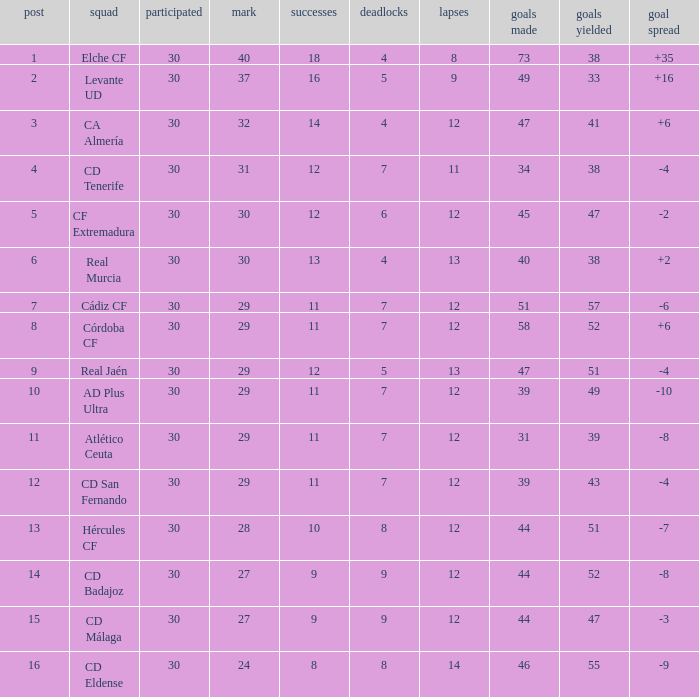What is the number of goals with less than 14 wins and a goal difference less than -4? 51, 39, 31, 44, 44, 46. 